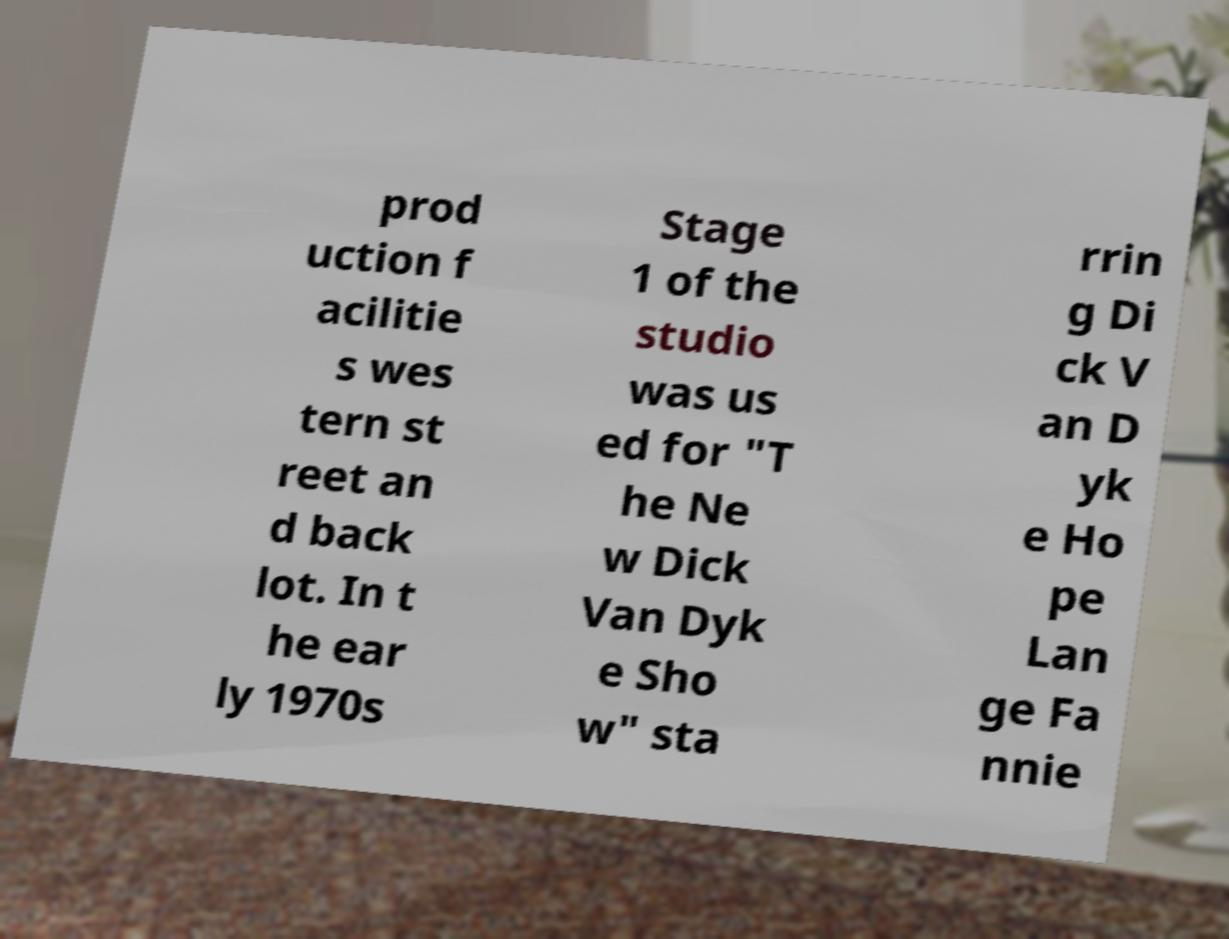Please identify and transcribe the text found in this image. prod uction f acilitie s wes tern st reet an d back lot. In t he ear ly 1970s Stage 1 of the studio was us ed for "T he Ne w Dick Van Dyk e Sho w" sta rrin g Di ck V an D yk e Ho pe Lan ge Fa nnie 